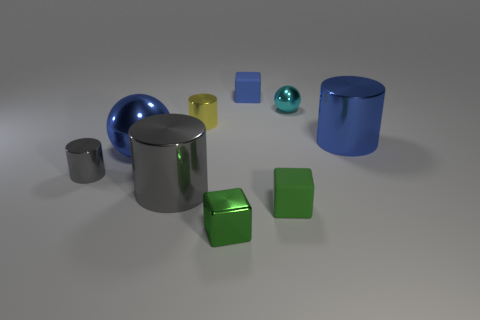Subtract all blue shiny cylinders. How many cylinders are left? 3 Add 1 yellow cylinders. How many objects exist? 10 Subtract all large metal balls. Subtract all big brown blocks. How many objects are left? 8 Add 1 yellow metallic cylinders. How many yellow metallic cylinders are left? 2 Add 1 cubes. How many cubes exist? 4 Subtract all blue blocks. How many blocks are left? 2 Subtract 1 cyan spheres. How many objects are left? 8 Subtract all cylinders. How many objects are left? 5 Subtract 3 cylinders. How many cylinders are left? 1 Subtract all purple cylinders. Subtract all red cubes. How many cylinders are left? 4 